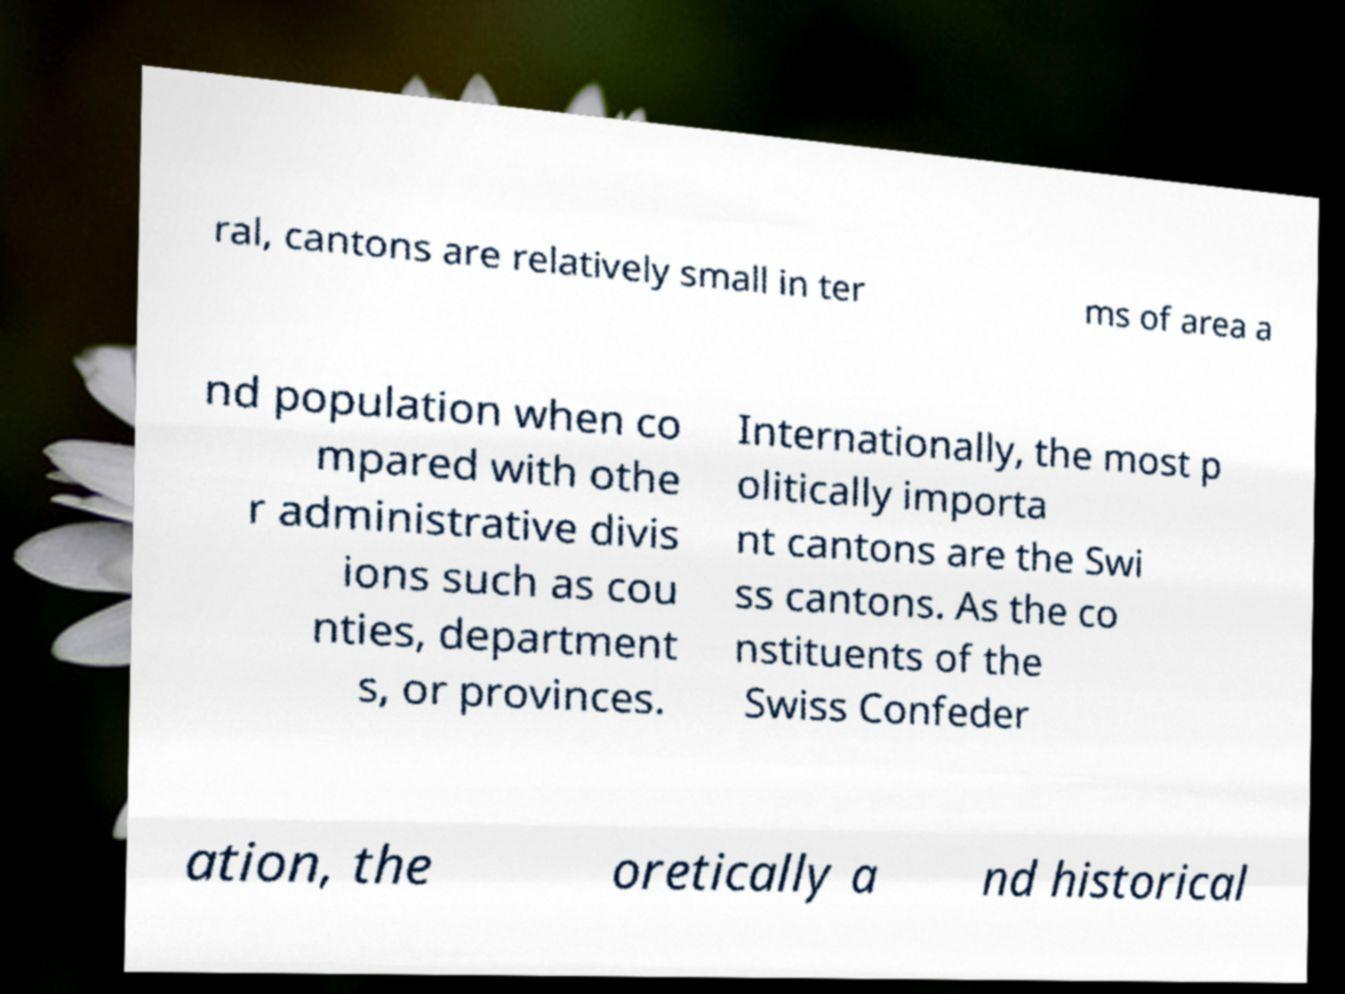There's text embedded in this image that I need extracted. Can you transcribe it verbatim? ral, cantons are relatively small in ter ms of area a nd population when co mpared with othe r administrative divis ions such as cou nties, department s, or provinces. Internationally, the most p olitically importa nt cantons are the Swi ss cantons. As the co nstituents of the Swiss Confeder ation, the oretically a nd historical 